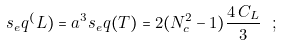Convert formula to latex. <formula><loc_0><loc_0><loc_500><loc_500>s _ { e } q ^ { ( } L ) = a ^ { 3 } s _ { e } q ( T ) = 2 ( N _ { c } ^ { 2 } - 1 ) \frac { 4 \, C _ { L } } { 3 } \ ;</formula> 